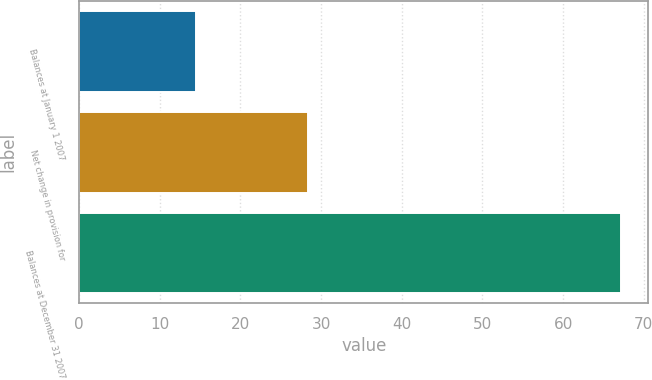<chart> <loc_0><loc_0><loc_500><loc_500><bar_chart><fcel>Balances at January 1 2007<fcel>Net change in provision for<fcel>Balances at December 31 2007<nl><fcel>14.5<fcel>28.4<fcel>67.2<nl></chart> 